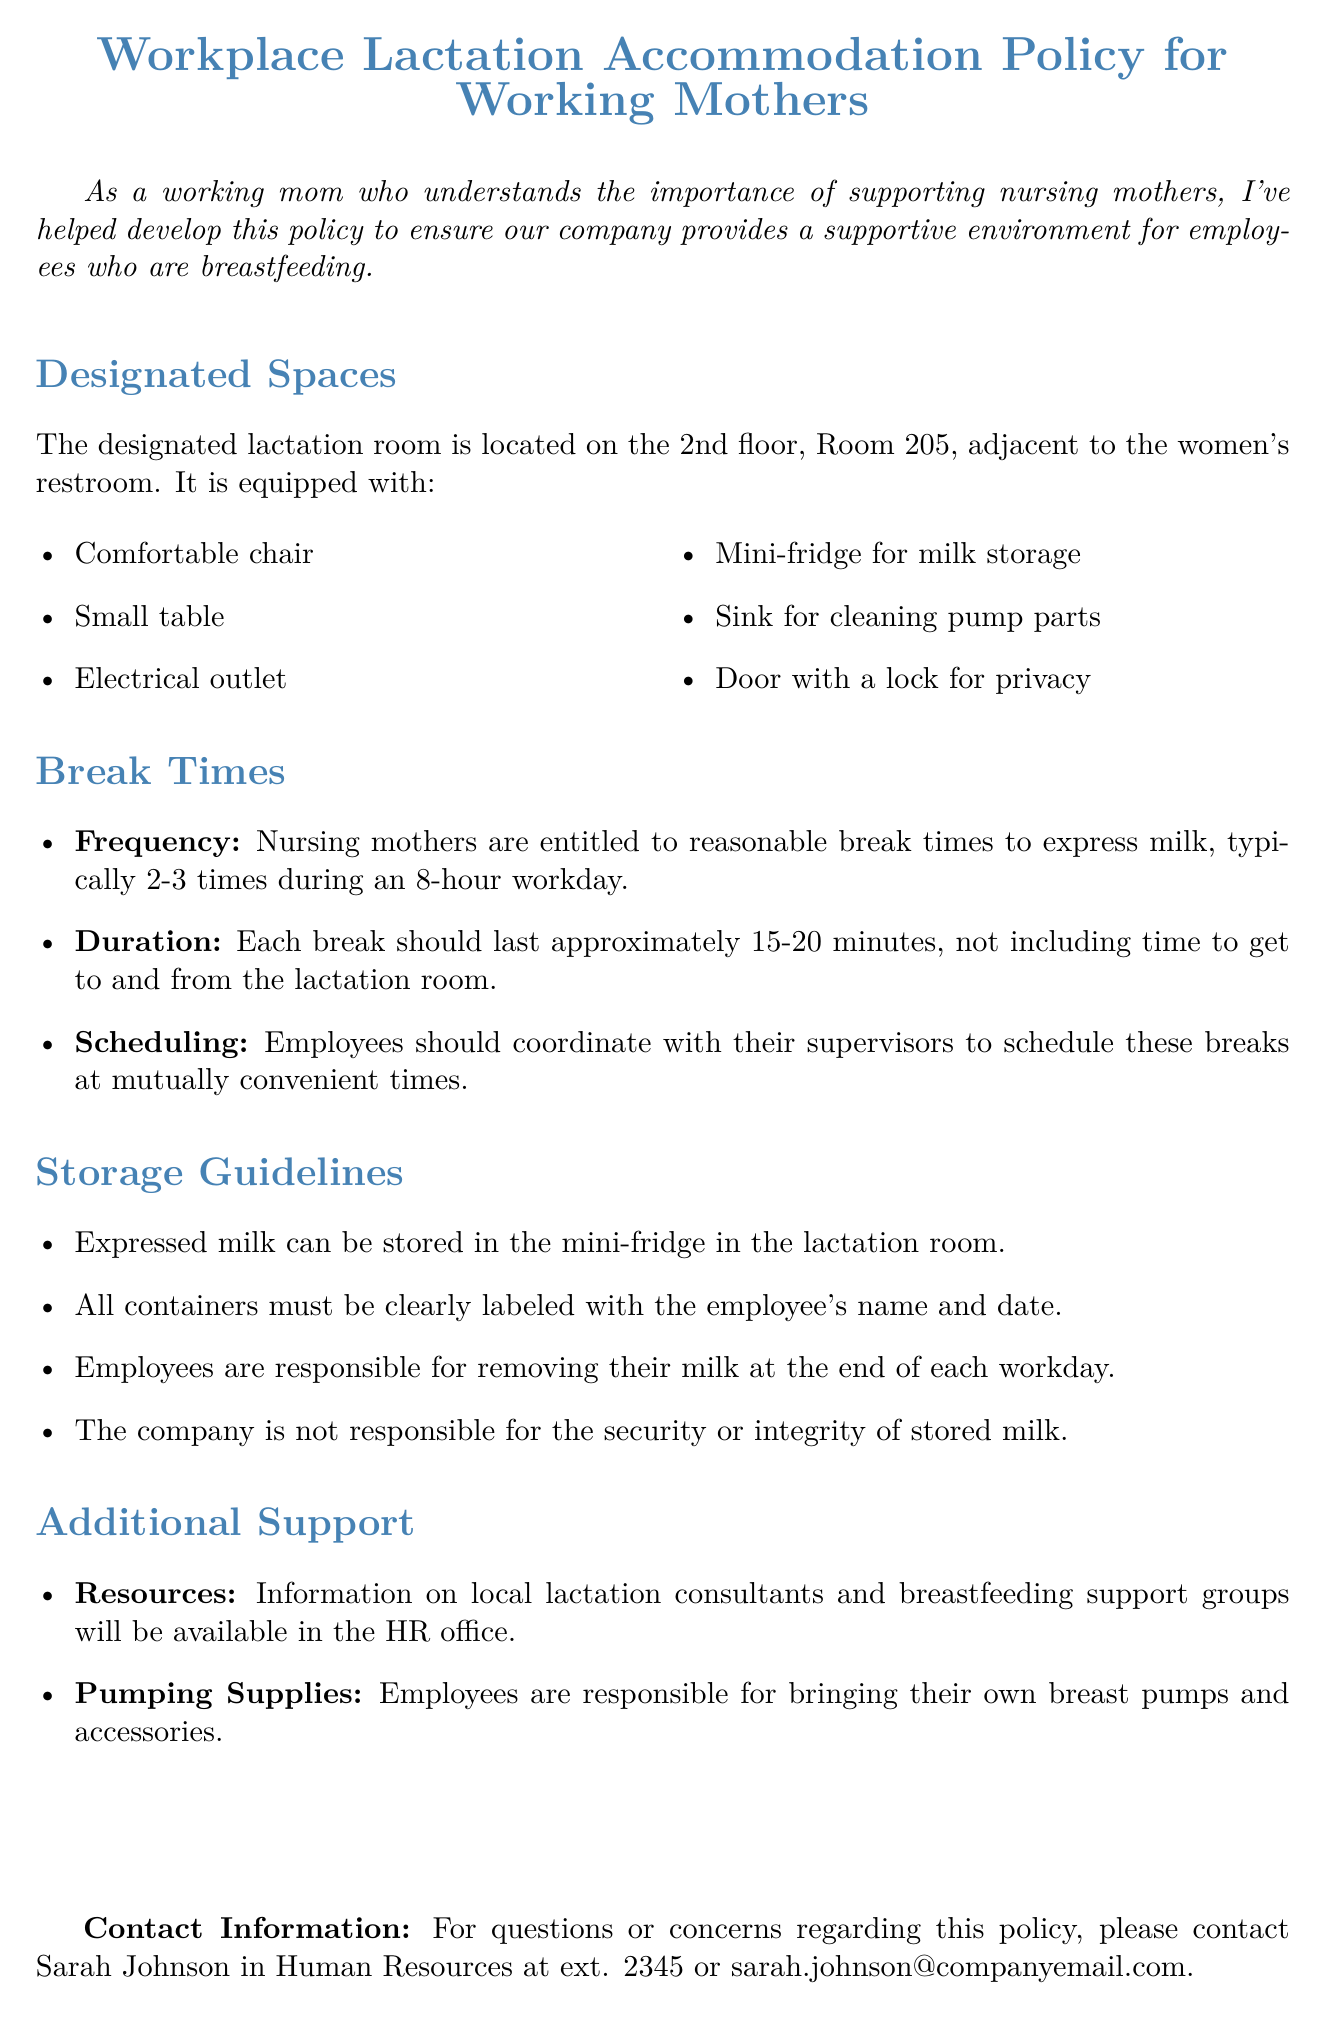What is the location of the designated lactation room? The designated lactation room is specifically mentioned to be on the 2nd floor, Room 205.
Answer: Room 205 How many times are nursing mothers entitled to break times during an 8-hour workday? The document states that nursing mothers are entitled to reasonable break times, typically 2-3 times during an 8-hour workday.
Answer: 2-3 times What equipment is provided in the lactation room for cleaning? The policy lists a sink as one of the amenities provided in the lactation room for cleaning pump parts.
Answer: Sink What is the recommended duration for each break? The document specifies that each break should last approximately 15-20 minutes.
Answer: 15-20 minutes Who should employees coordinate with to schedule their break times? The policy advises employees to coordinate with their supervisors for scheduling their break times.
Answer: Supervisors What must be included on milk storage containers? The document clearly states that all containers must be labeled with the employee's name and date.
Answer: Name and date What is available in the HR office for additional support? The document mentions that information on local lactation consultants and breastfeeding support groups will be available in the HR office.
Answer: Lactation consultants and support groups What is the company's responsibility regarding stored milk? The policy indicates that the company is not responsible for the security or integrity of stored milk.
Answer: Not responsible What is the contact person's name for questions about the policy? The document provides Sarah Johnson in Human Resources as the contact person for questions or concerns regarding the policy.
Answer: Sarah Johnson 